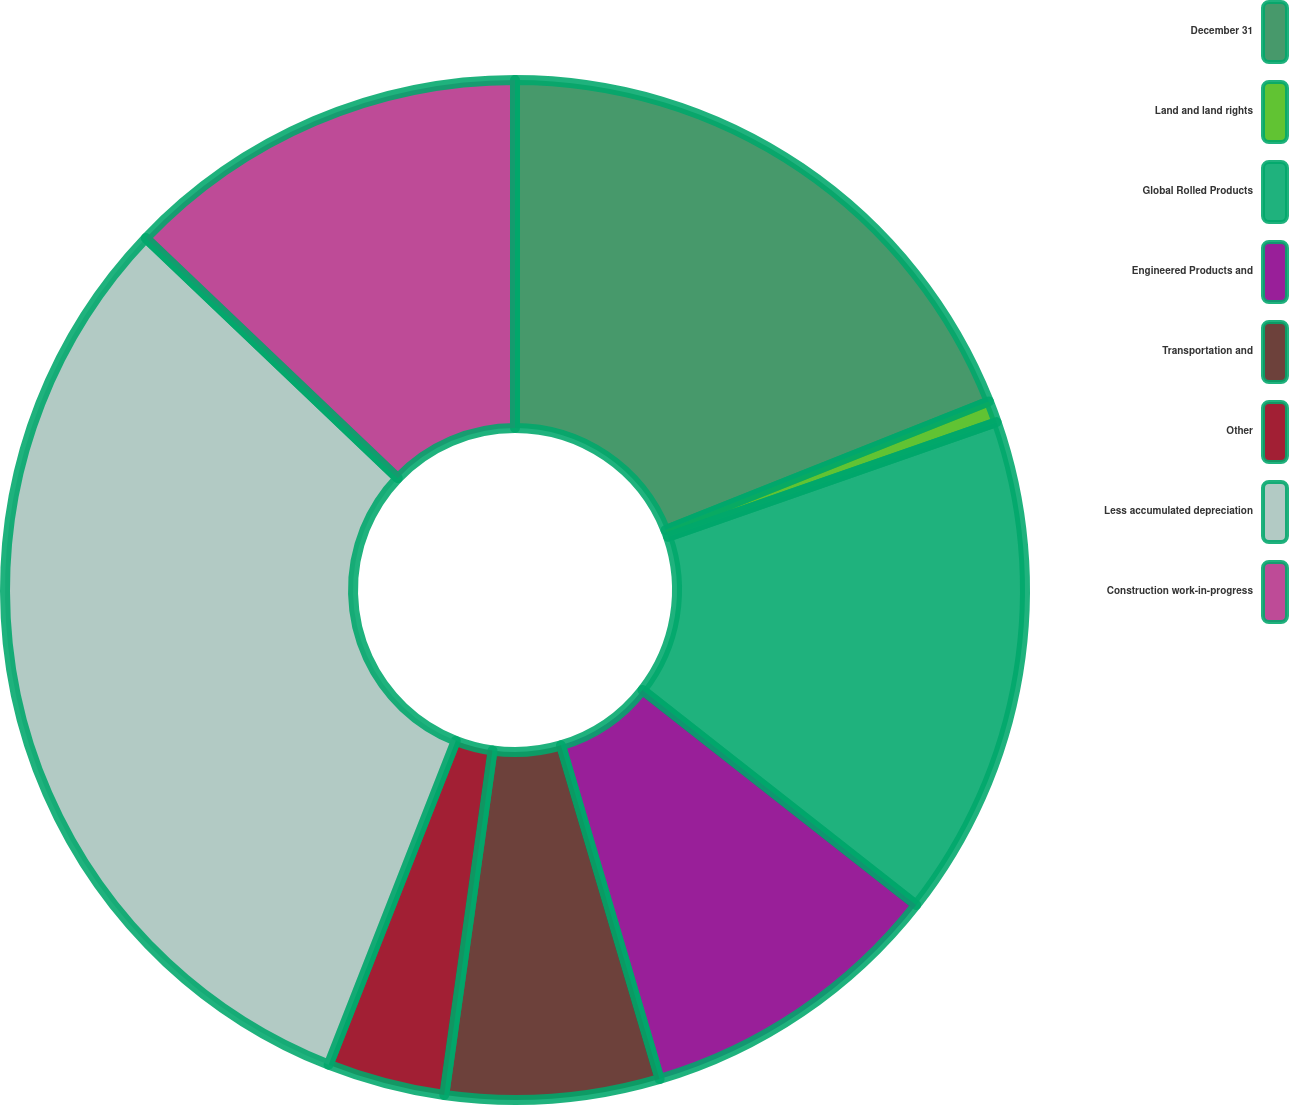<chart> <loc_0><loc_0><loc_500><loc_500><pie_chart><fcel>December 31<fcel>Land and land rights<fcel>Global Rolled Products<fcel>Engineered Products and<fcel>Transportation and<fcel>Other<fcel>Less accumulated depreciation<fcel>Construction work-in-progress<nl><fcel>18.97%<fcel>0.69%<fcel>15.93%<fcel>9.83%<fcel>6.79%<fcel>3.74%<fcel>31.16%<fcel>12.88%<nl></chart> 